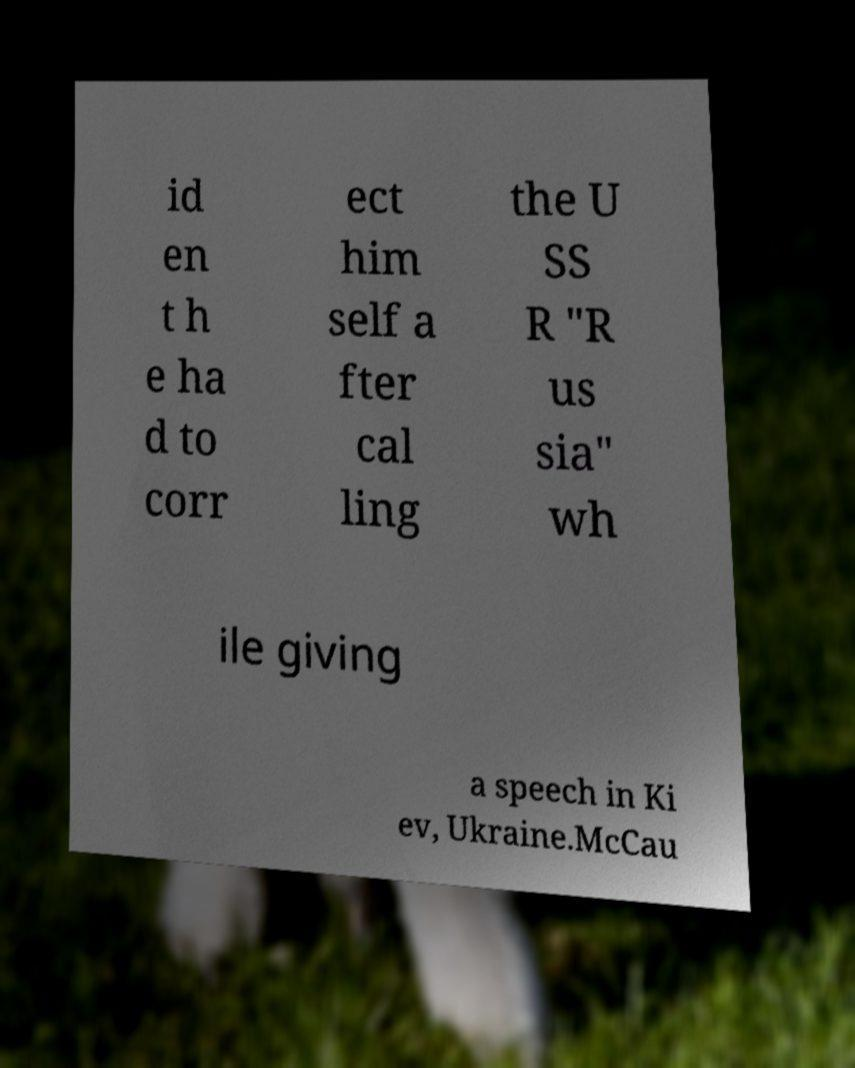Could you extract and type out the text from this image? id en t h e ha d to corr ect him self a fter cal ling the U SS R "R us sia" wh ile giving a speech in Ki ev, Ukraine.McCau 